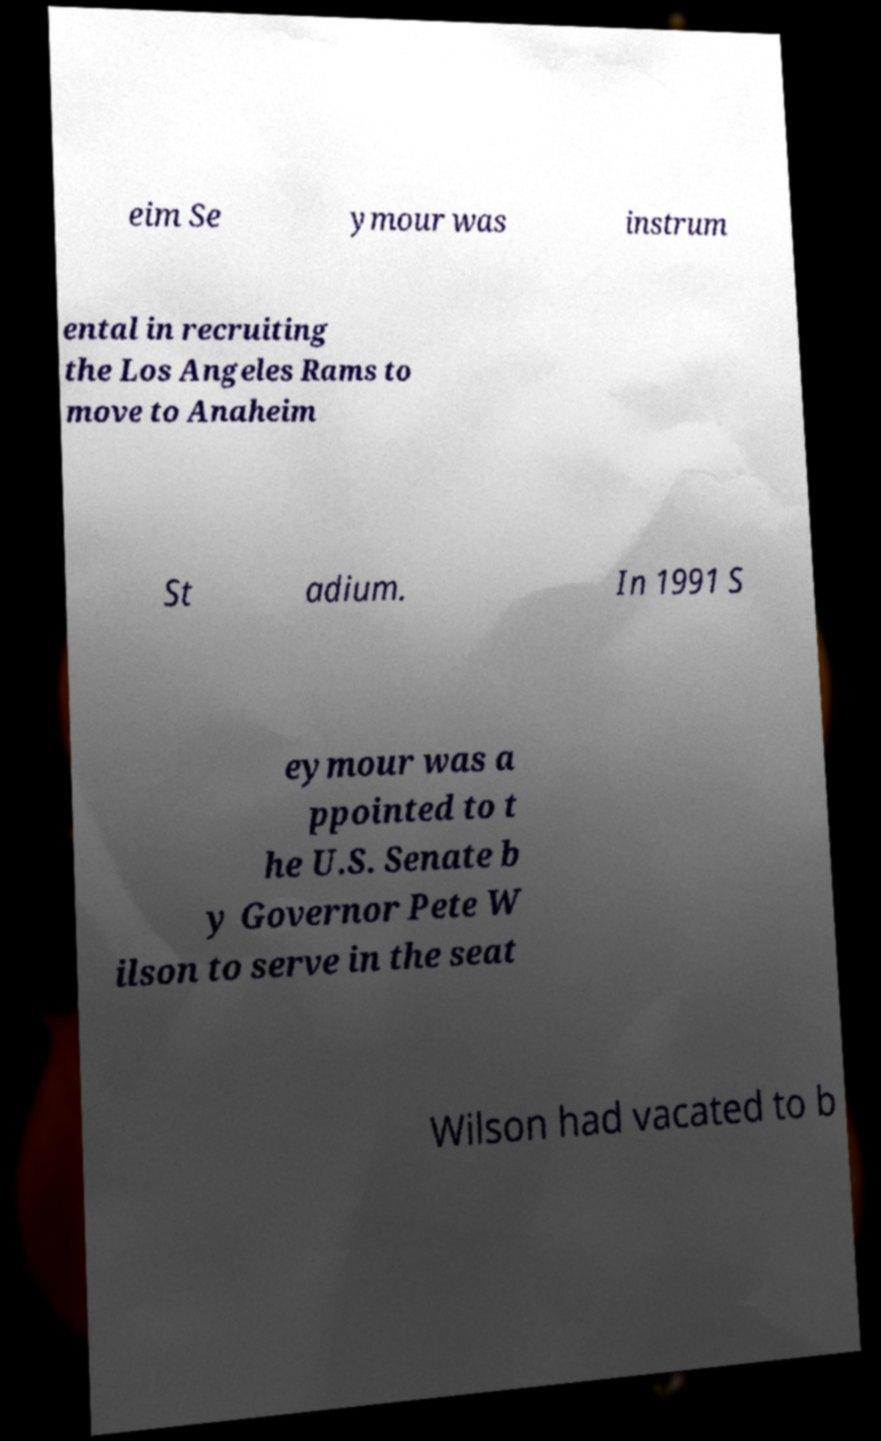Can you read and provide the text displayed in the image?This photo seems to have some interesting text. Can you extract and type it out for me? eim Se ymour was instrum ental in recruiting the Los Angeles Rams to move to Anaheim St adium. In 1991 S eymour was a ppointed to t he U.S. Senate b y Governor Pete W ilson to serve in the seat Wilson had vacated to b 